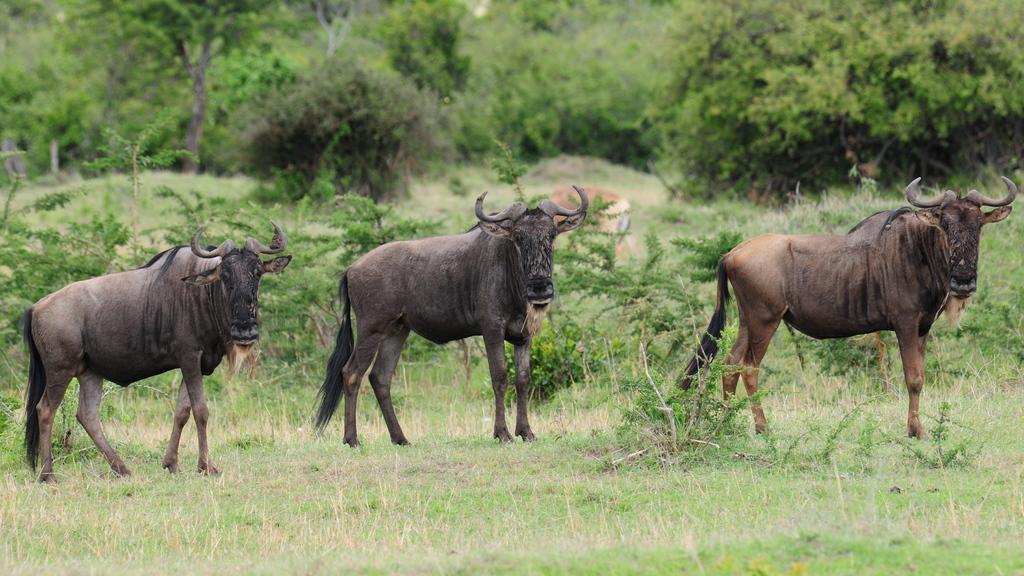How would you summarize this image in a sentence or two? In the picture we can see a grass surface on it we can see the forest buffaloes and in the background we can see plants, trees. 